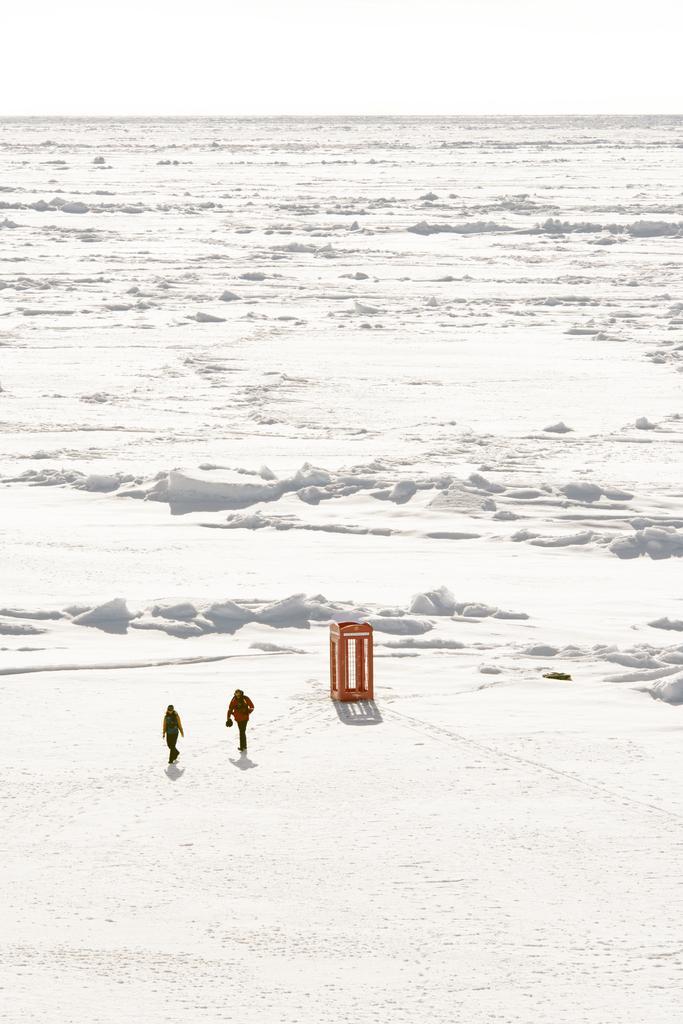How would you summarize this image in a sentence or two? In this image we can see snow, persons on the snow and a cage. In the background there is sky. 